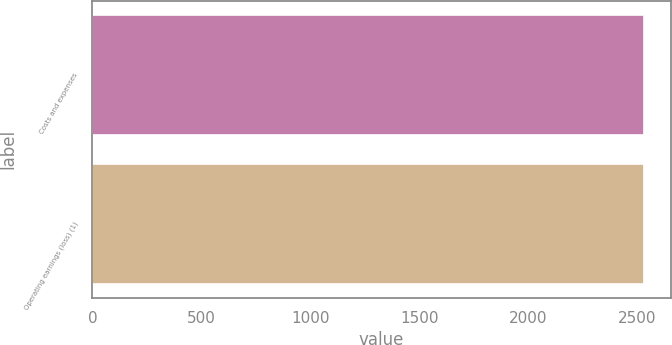<chart> <loc_0><loc_0><loc_500><loc_500><bar_chart><fcel>Costs and expenses<fcel>Operating earnings (loss) (1)<nl><fcel>2528<fcel>2528.1<nl></chart> 